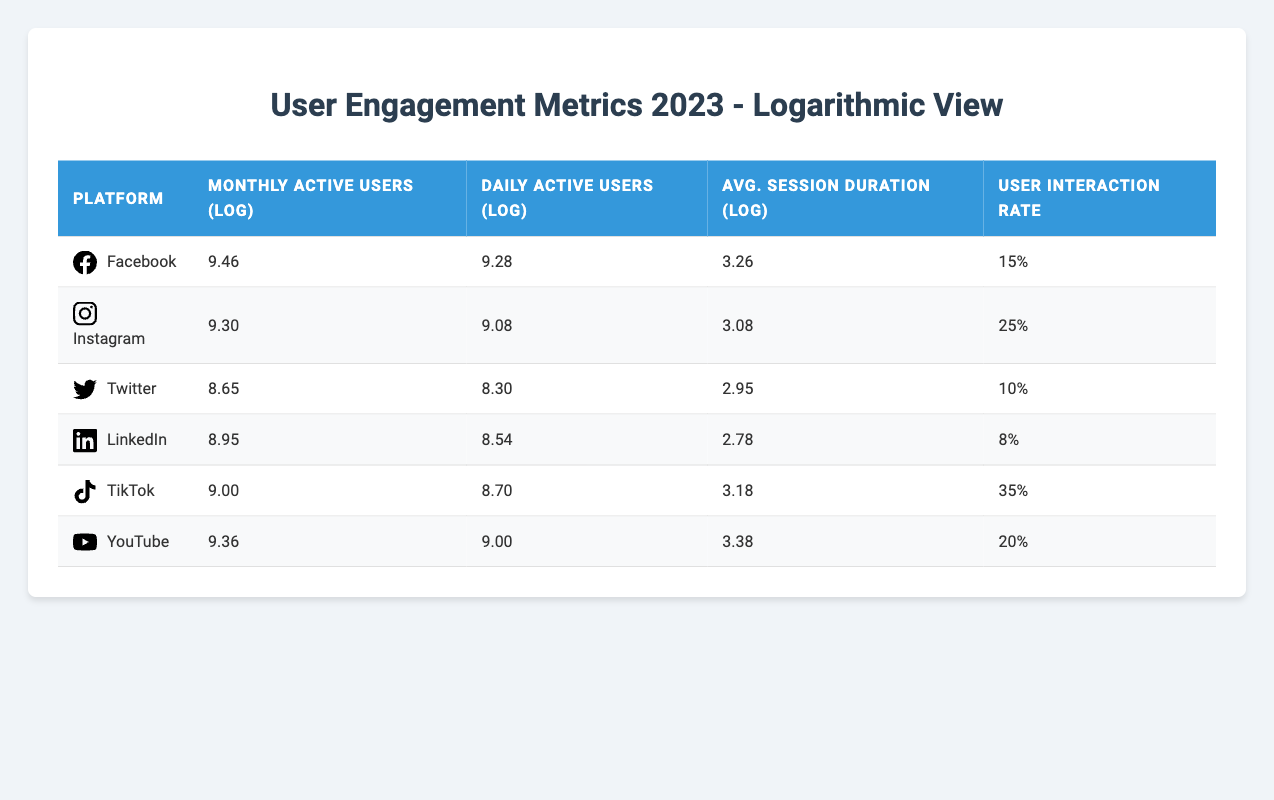What is the platform with the highest number of daily active users? Referring to the table, Facebook has 1,900,000,000 daily active users, which is higher than all other platforms listed.
Answer: Facebook What is the logarithmic value for the average session duration of YouTube? The table shows that the average session duration for YouTube is represented as 3.38 in logarithmic terms.
Answer: 3.38 Which platform has the lowest user interaction rate? By examining the user interaction rates, LinkedIn has the lowest percentage at 8%.
Answer: LinkedIn What is the difference between the logarithmic values of monthly active users for Instagram and TikTok? The logarithmic value for Instagram is 9.30, and for TikTok, it is 9.00. The difference can be calculated as 9.30 - 9.00 = 0.30.
Answer: 0.30 Is TikTok's daily active user logarithmic value greater than that of Twitter? TikTok has a logarithmic value of 8.70 for daily active users, while Twitter's value is 8.30. Since 8.70 > 8.30, the statement is true.
Answer: Yes What is the average user interaction rate for the platforms listed? To find the average, sum all interaction rates (15 + 25 + 10 + 8 + 35 + 20) = 113 and divide by the number of platforms, which is 6, resulting in 113/6 = 18.83%.
Answer: 18.83% Which platform has the highest logarithmic value for daily active users? The daily active user logarithmic values are as follows: Facebook - 9.28, Instagram - 9.08, Twitter - 8.30, LinkedIn - 8.54, TikTok - 8.70, and YouTube - 9.00. The highest value is Facebook at 9.28.
Answer: Facebook How does the average session duration of YouTube compare to that of Facebook? The average session duration for YouTube is 3.38 while for Facebook it's 3.26. Since 3.38 > 3.26, YouTube has a greater average session duration.
Answer: YouTube What is the total number of monthly active users for all platforms combined? Monthly active users: Facebook (2,900,000,000) + Instagram (2,000,000,000) + Twitter (450,000,000) + LinkedIn (900,000,000) + TikTok (1,000,000,000) + YouTube (2,300,000,000) = 9,600,000,000.
Answer: 9,600,000,000 